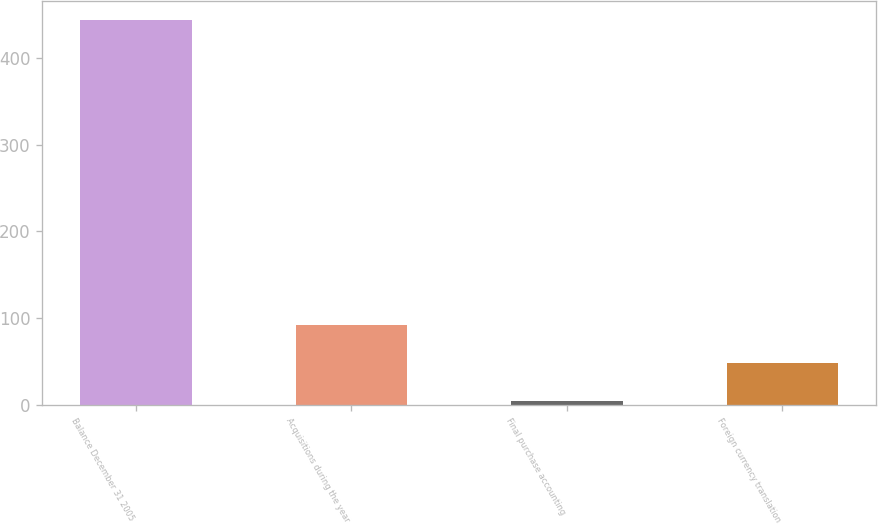<chart> <loc_0><loc_0><loc_500><loc_500><bar_chart><fcel>Balance December 31 2005<fcel>Acquisitions during the year<fcel>Final purchase accounting<fcel>Foreign currency translation<nl><fcel>443.4<fcel>92.2<fcel>4.4<fcel>48.3<nl></chart> 